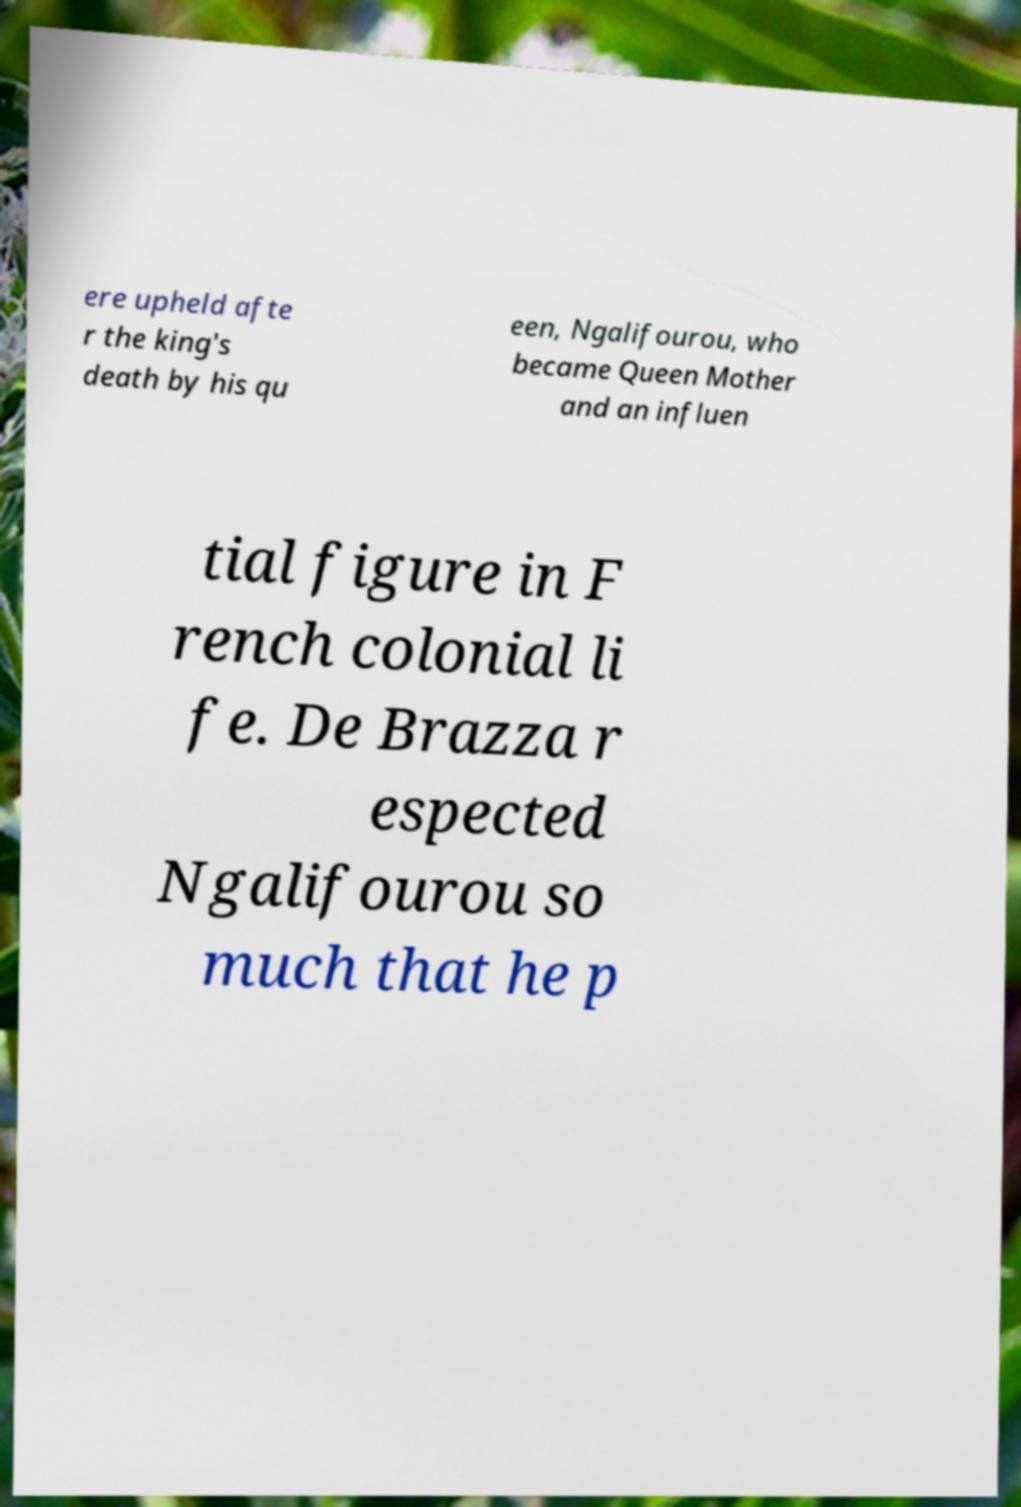For documentation purposes, I need the text within this image transcribed. Could you provide that? ere upheld afte r the king's death by his qu een, Ngalifourou, who became Queen Mother and an influen tial figure in F rench colonial li fe. De Brazza r espected Ngalifourou so much that he p 